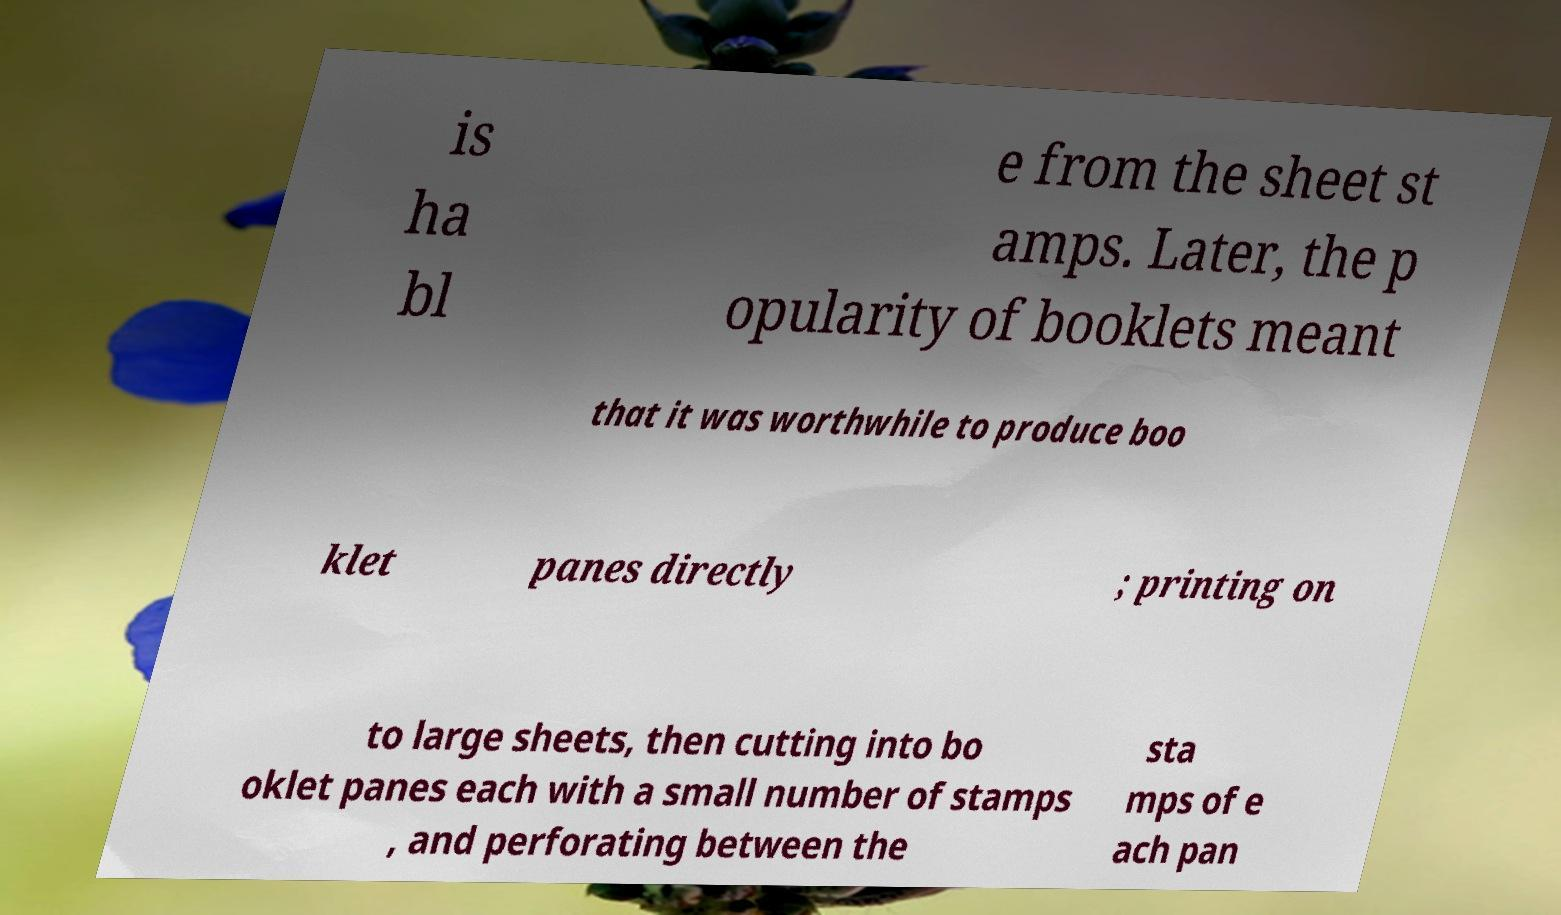For documentation purposes, I need the text within this image transcribed. Could you provide that? is ha bl e from the sheet st amps. Later, the p opularity of booklets meant that it was worthwhile to produce boo klet panes directly ; printing on to large sheets, then cutting into bo oklet panes each with a small number of stamps , and perforating between the sta mps of e ach pan 